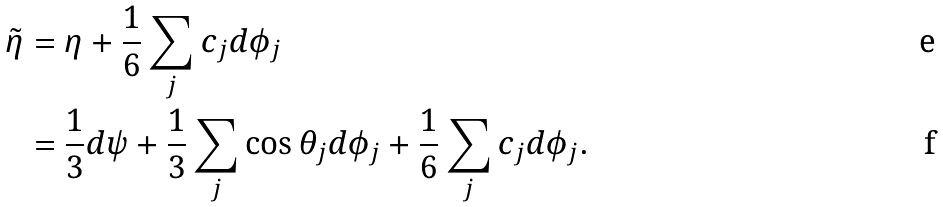Convert formula to latex. <formula><loc_0><loc_0><loc_500><loc_500>\tilde { \eta } & = \eta + \frac { 1 } { 6 } \sum _ { j } c _ { j } d \phi _ { j } \\ & = \frac { 1 } { 3 } d \psi + \frac { 1 } { 3 } \sum _ { j } \cos \theta _ { j } d \phi _ { j } + \frac { 1 } { 6 } \sum _ { j } c _ { j } d \phi _ { j } .</formula> 